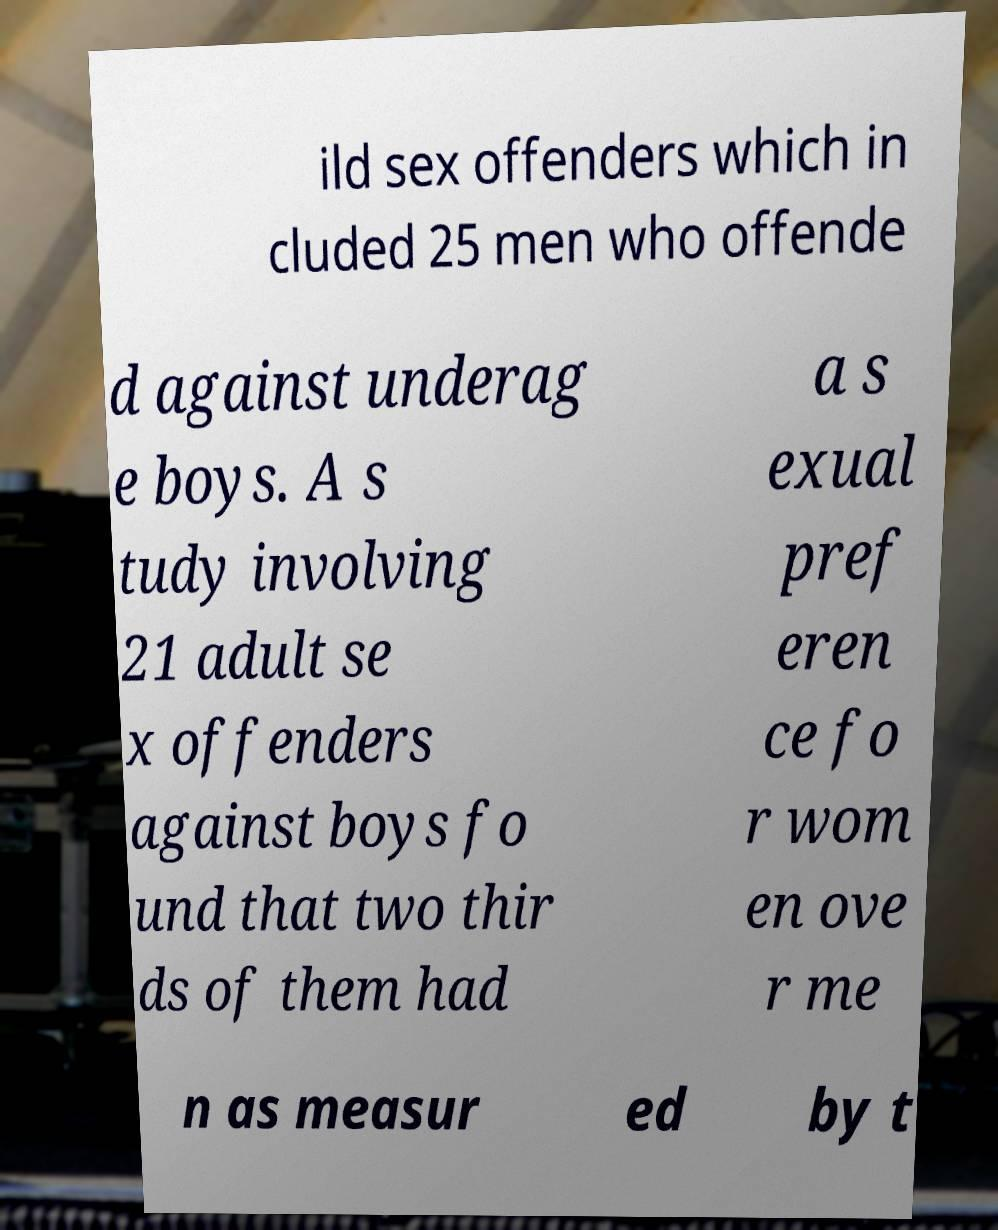Could you assist in decoding the text presented in this image and type it out clearly? ild sex offenders which in cluded 25 men who offende d against underag e boys. A s tudy involving 21 adult se x offenders against boys fo und that two thir ds of them had a s exual pref eren ce fo r wom en ove r me n as measur ed by t 